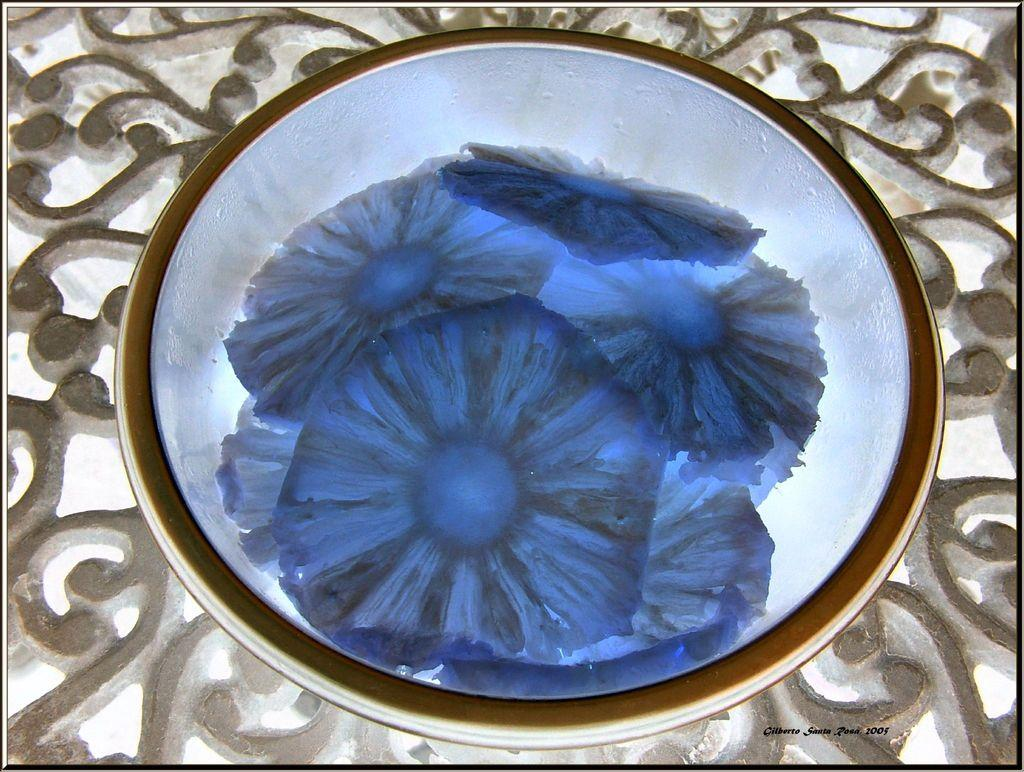What is the main object in the image? There is a bowl in the image. Where is the bowl located? The bowl is placed on concrete fencing. What can be seen in the center of the bowl? There is a flower design in the center of the bowl. What type of trouble is the flower design causing in the image? There is no trouble mentioned or depicted in the image, and the flower design is not causing any issues. 